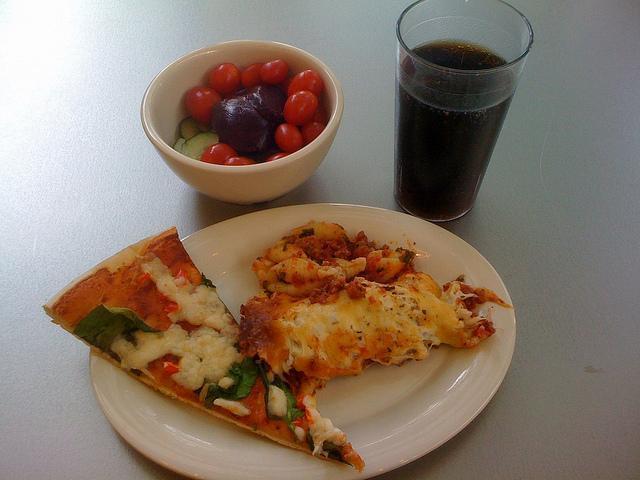How many glasses are there?
Give a very brief answer. 1. How many pizzas are there?
Give a very brief answer. 2. How many train cars are attached to the train's engine?
Give a very brief answer. 0. 